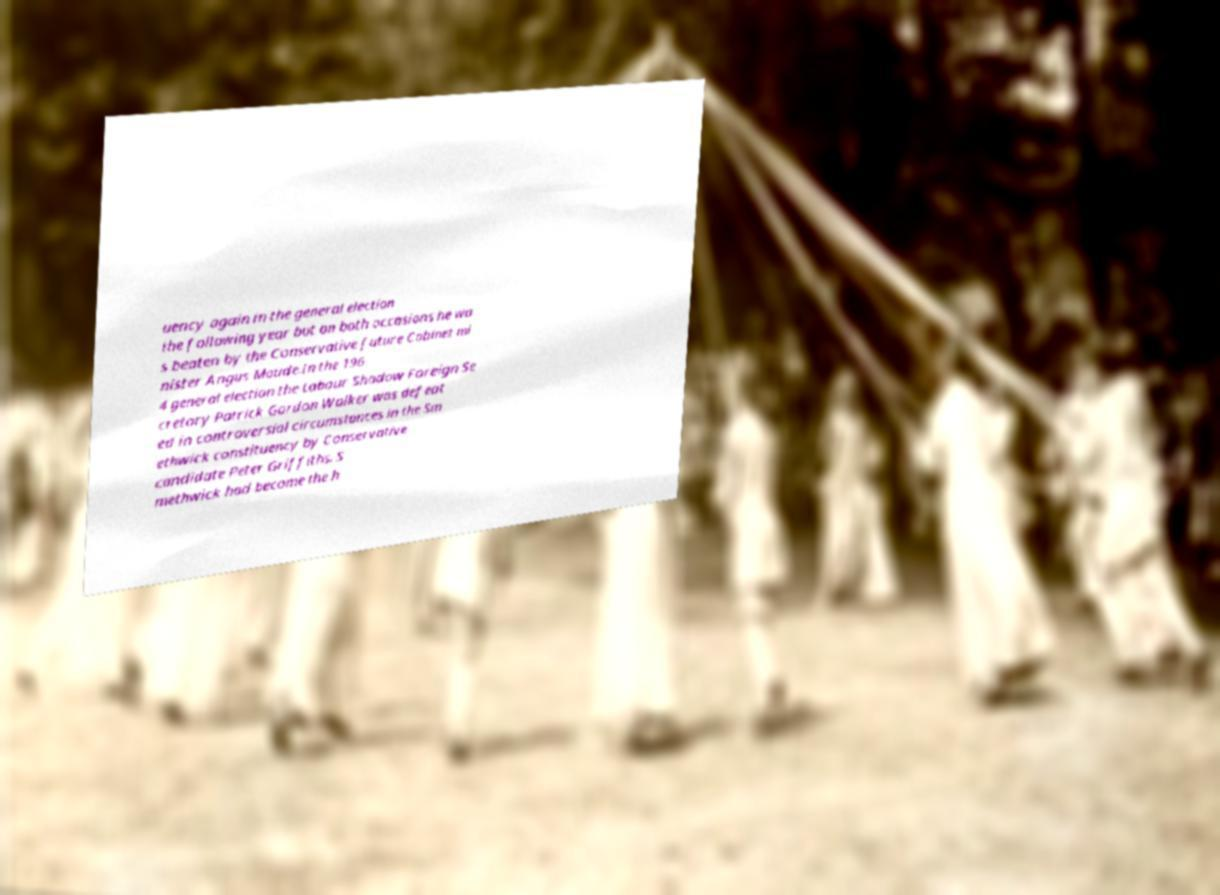Can you read and provide the text displayed in the image?This photo seems to have some interesting text. Can you extract and type it out for me? uency again in the general election the following year but on both occasions he wa s beaten by the Conservative future Cabinet mi nister Angus Maude.In the 196 4 general election the Labour Shadow Foreign Se cretary Patrick Gordon Walker was defeat ed in controversial circumstances in the Sm ethwick constituency by Conservative candidate Peter Griffiths. S methwick had become the h 